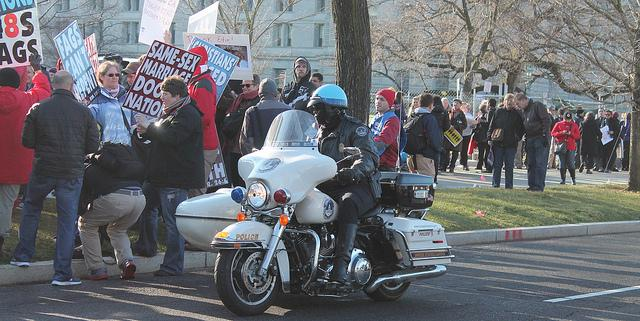What sort of sex is everyone here thinking about? homosexual 